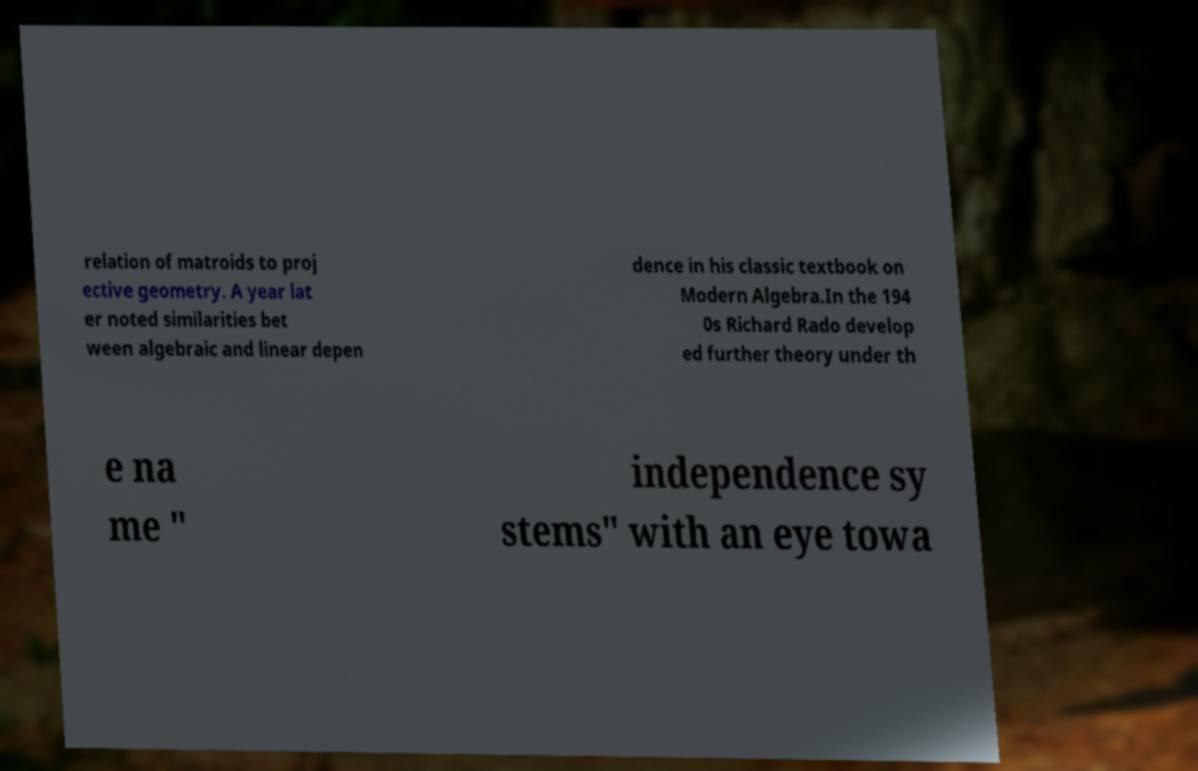Could you extract and type out the text from this image? relation of matroids to proj ective geometry. A year lat er noted similarities bet ween algebraic and linear depen dence in his classic textbook on Modern Algebra.In the 194 0s Richard Rado develop ed further theory under th e na me " independence sy stems" with an eye towa 